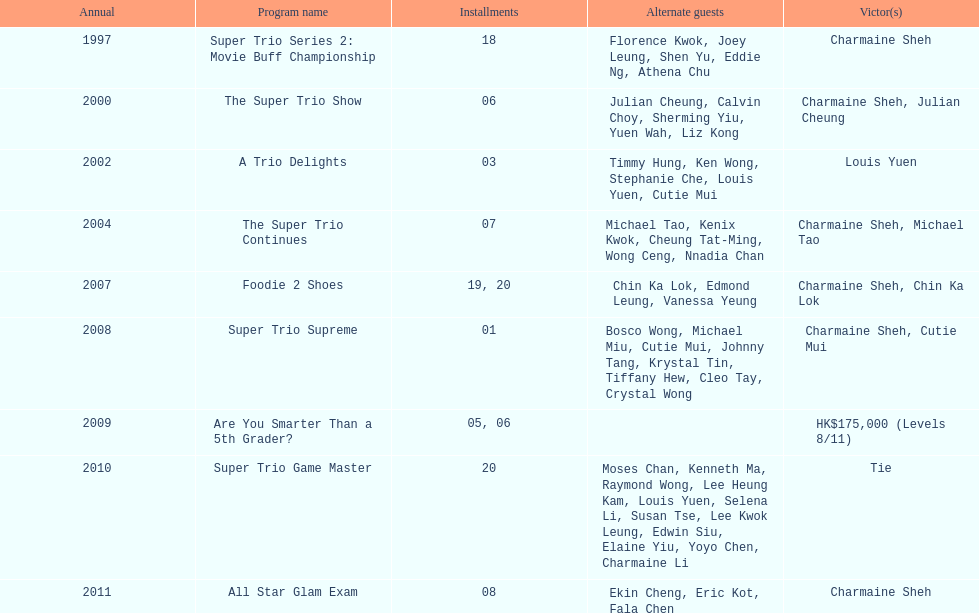What was the aggregate number of trio series presentations with charmaine sheh? 6. 